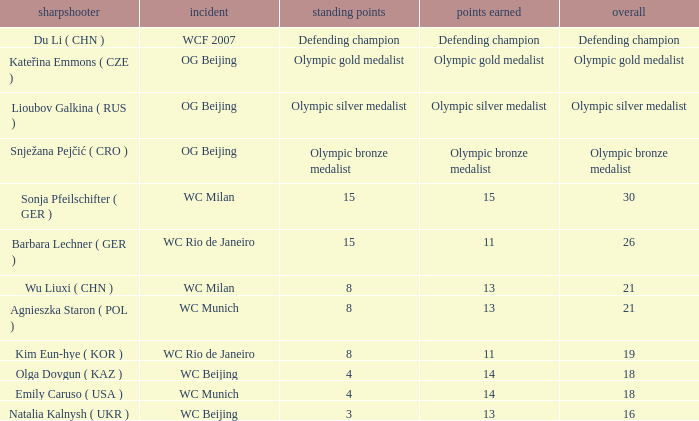Which event had a total of defending champion? WCF 2007. 